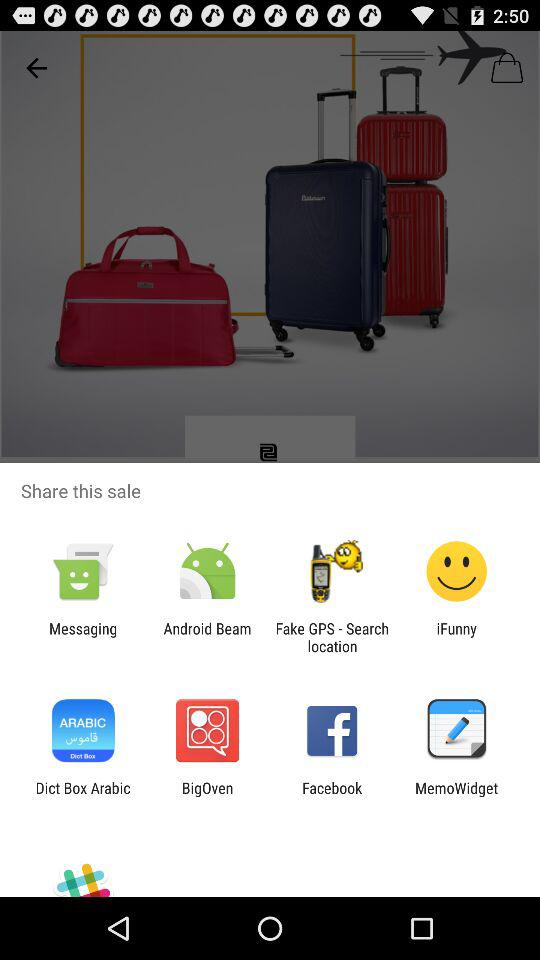Which applications can we use to share? You can use "Messaging", "Android Beam", "Fake GPS - Search location", "iFunny", "Dict Box Arabic", "BigOven", "Facebook" and "MemoWidget" to share. 